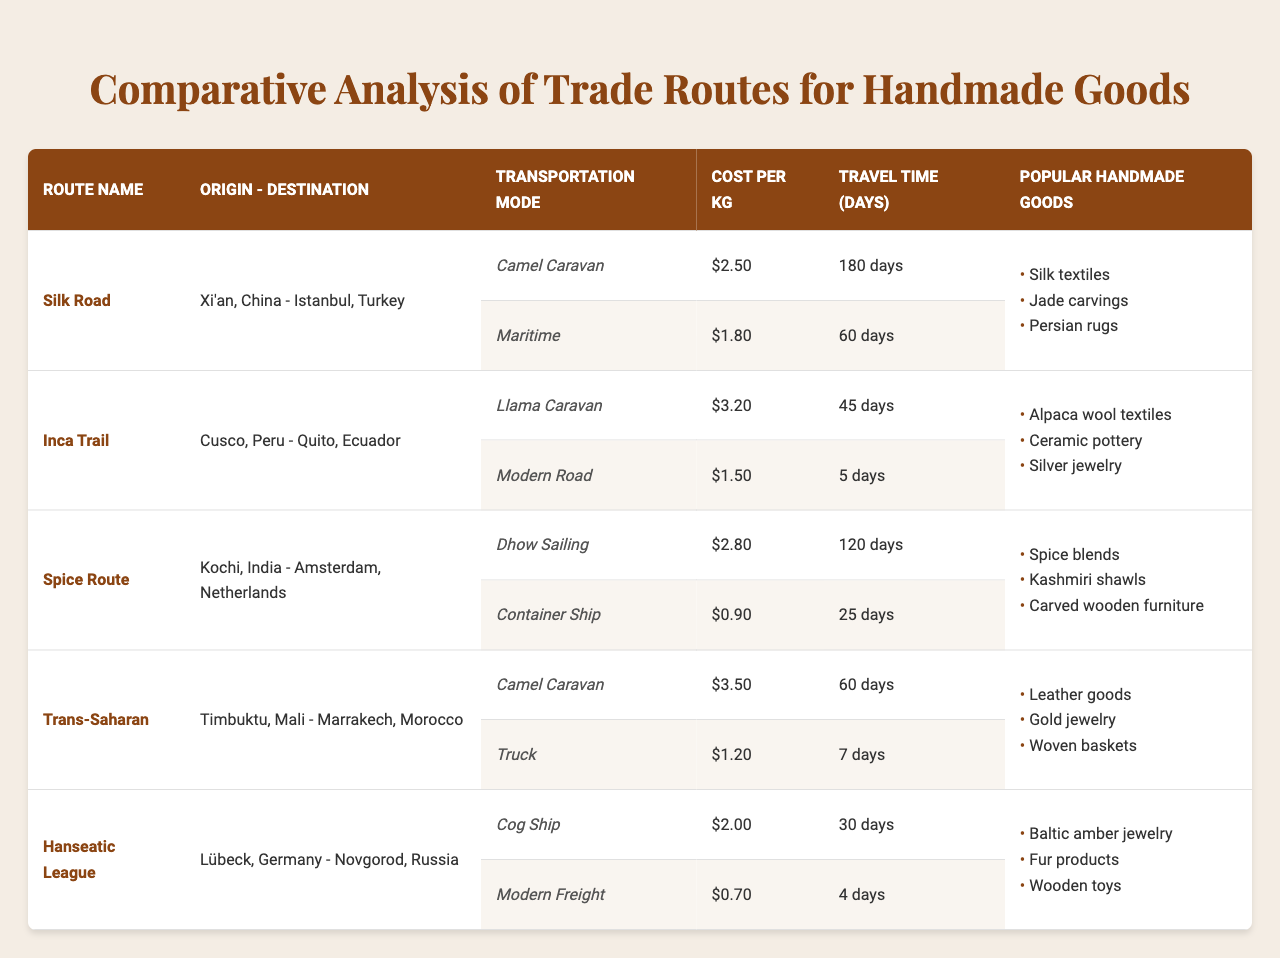What are the popular handmade goods transported via the Spice Route? The Spice Route has a listed item of popular handmade goods that includes spice blends, Kashmiri shawls, and carved wooden furniture.
Answer: Spice blends, Kashmiri shawls, carved wooden furniture What is the cost per kg for transporting goods using a Dhow Sailing on the Spice Route? The table specifies that the cost per kg for Dhow Sailing on the Spice Route is $2.8.
Answer: $2.8 Which transportation mode on the Inca Trail has the longest travel time? By comparing the travel times for the Llama Caravan (45 days) and the Modern Road (5 days), the Llama Caravan has the longest travel time.
Answer: Llama Caravan Is the transportation cost for the container ship on the Spice Route lower than that of the camel caravan on the Trans-Saharan route? The cost for the container ship is $0.9 per kg, while the camel caravan on the Trans-Saharan route costs $3.5 per kg, hence the container ship cost is lower.
Answer: Yes What is the total travel time for transporting goods from Xi'an to Istanbul using both modes on the Silk Road? The travel time for the Camel Caravan is 180 days and for Maritime is 60 days. Summing these gives 180 + 60 = 240 days.
Answer: 240 days Which trade route has the highest cost per kg for its transportation modes? By examining all costs per kg, the Llama Caravan on the Inca Trail at $3.2 is the highest. Compared to others, it surpasses costs from the Silk Road, Spice Route, Trans-Saharan, and Hanseatic League.
Answer: Inca Trail If you were to choose the most time-efficient route for transporting goods, which route would you select and why? The Modern Road on the Inca Trail has the lowest travel time of 5 days, significantly lower than all other options. Therefore, it's the most time-efficient option.
Answer: Inca Trail What is the average cost per kg for the transportation modes on the Hanseatic League? The transportation modes for the Hanseatic League (Cog Ship at $2.0, Modern Freight at $0.7) gives us an average of (2.0 + 0.7) / 2 = 1.35.
Answer: $1.35 Do all trade routes feature maritime transportation modes? Only the Silk Road and the Spice Route show maritime modes; Inca Trail, Trans-Saharan, and Hanseatic League do not. Thus, not all routes feature maritime options.
Answer: No Which trade route uses the same transportation mode but has different costs? The Camel Caravan is used in both the Silk Road and Trans-Saharan routes with respective costs of $2.5 and $3.5 per kg. This indicates a difference in cost despite the same transport mode.
Answer: Yes 